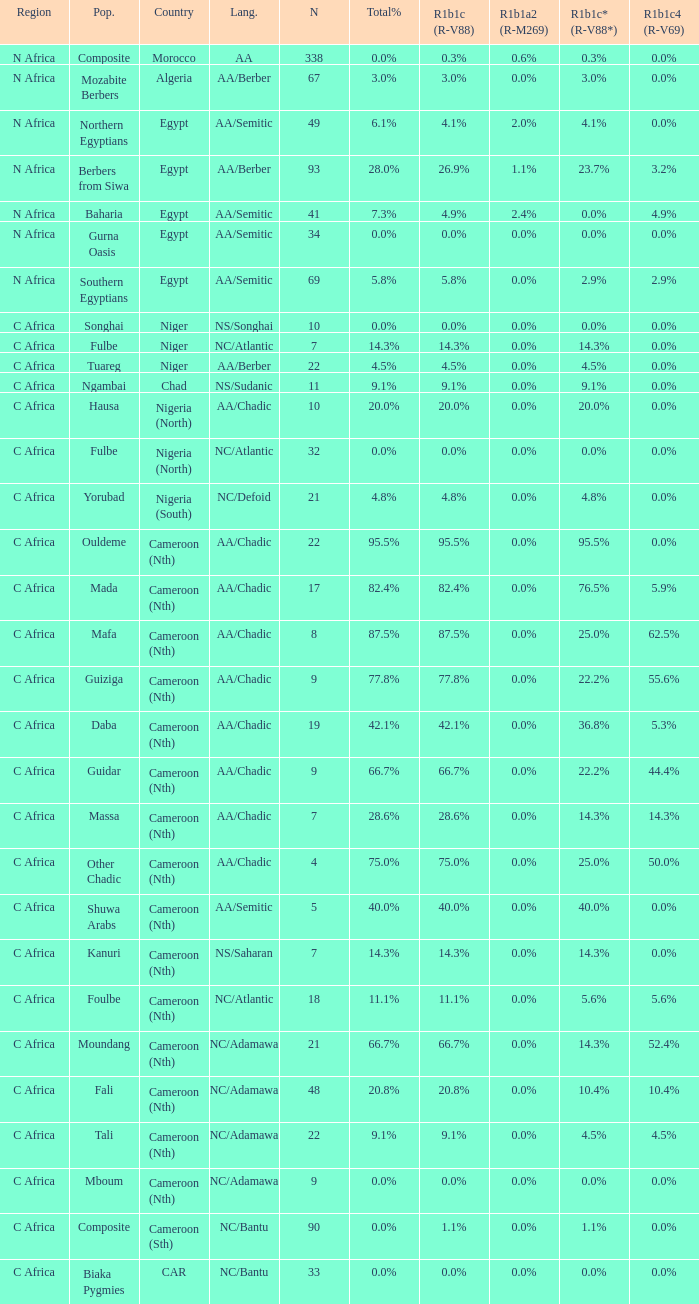How many n are listed for berbers from siwa? 1.0. 